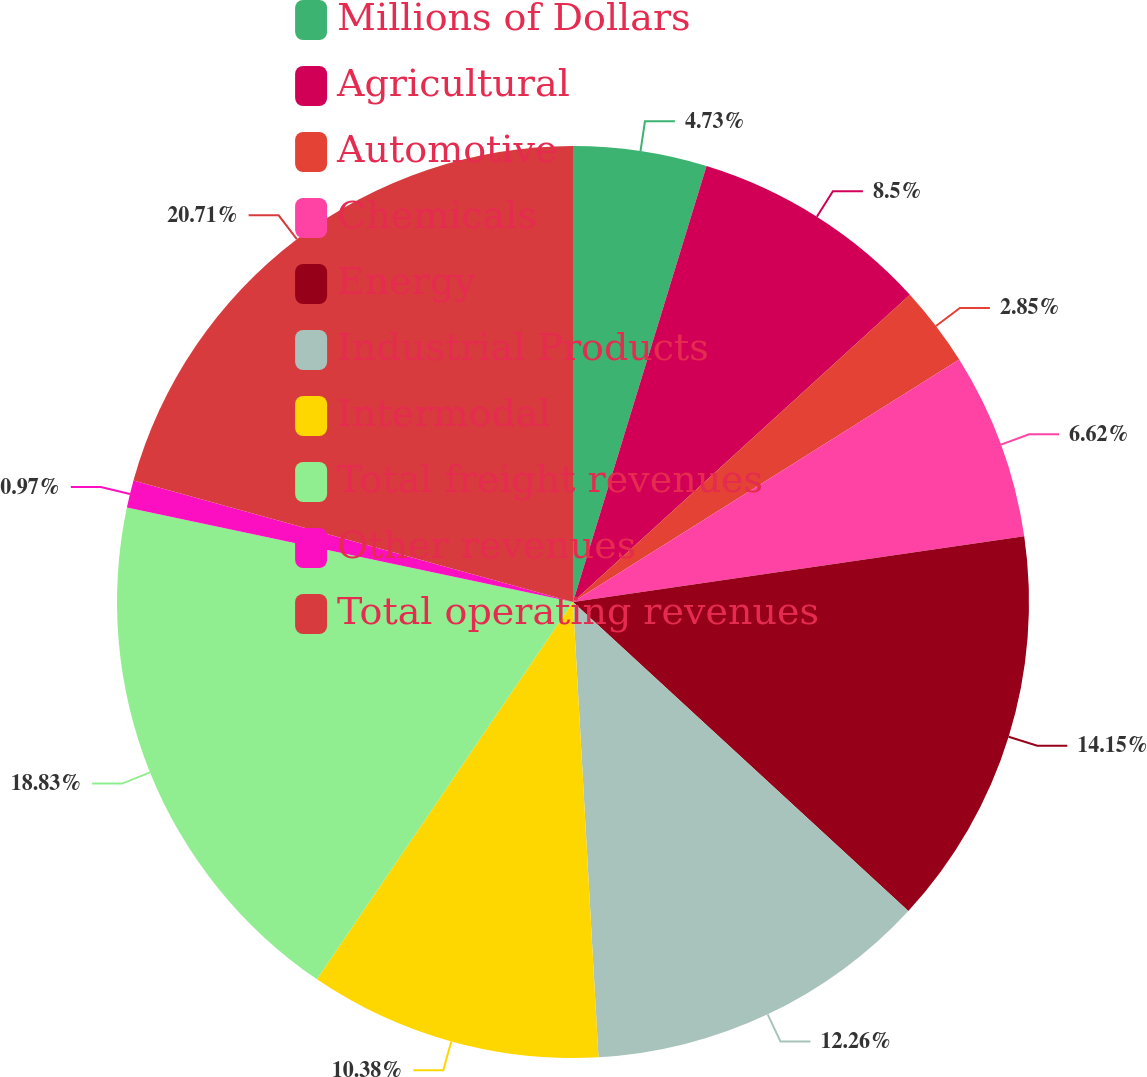Convert chart to OTSL. <chart><loc_0><loc_0><loc_500><loc_500><pie_chart><fcel>Millions of Dollars<fcel>Agricultural<fcel>Automotive<fcel>Chemicals<fcel>Energy<fcel>Industrial Products<fcel>Intermodal<fcel>Total freight revenues<fcel>Other revenues<fcel>Total operating revenues<nl><fcel>4.73%<fcel>8.5%<fcel>2.85%<fcel>6.62%<fcel>14.15%<fcel>12.26%<fcel>10.38%<fcel>18.83%<fcel>0.97%<fcel>20.71%<nl></chart> 